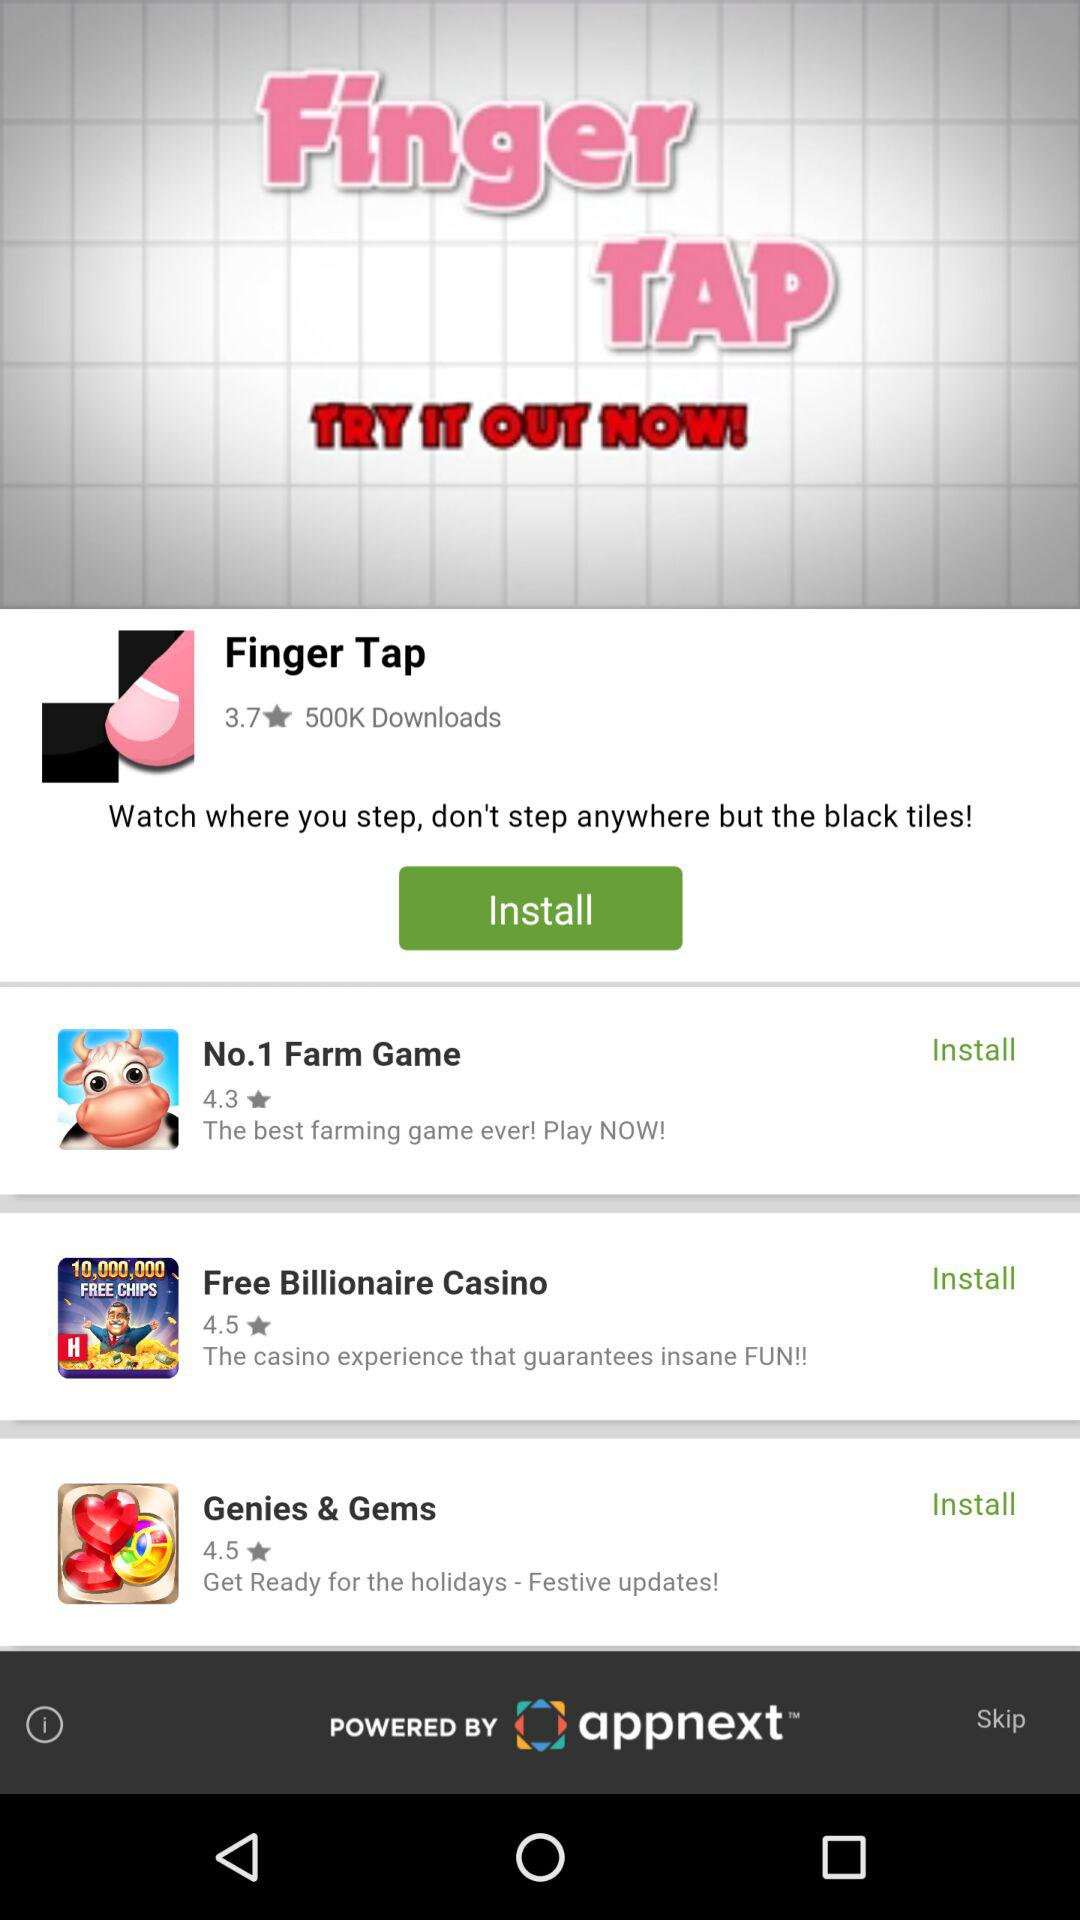What's the rating for "No.1 Farm Game"? The rating is 4.3. 